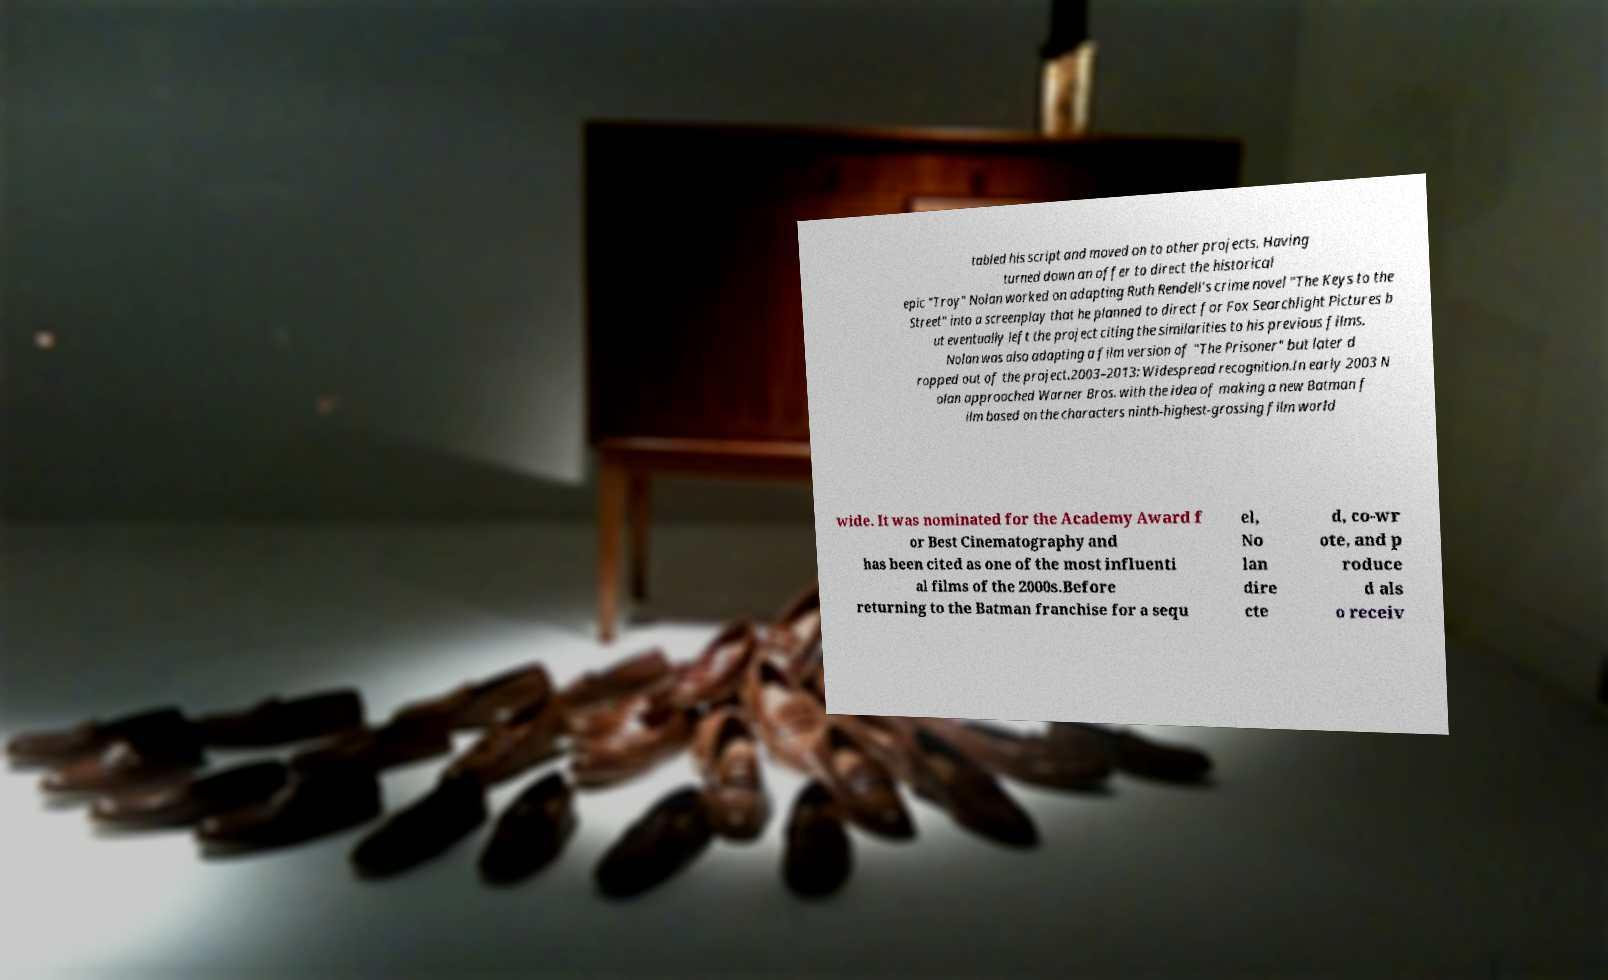Could you assist in decoding the text presented in this image and type it out clearly? tabled his script and moved on to other projects. Having turned down an offer to direct the historical epic "Troy" Nolan worked on adapting Ruth Rendell's crime novel "The Keys to the Street" into a screenplay that he planned to direct for Fox Searchlight Pictures b ut eventually left the project citing the similarities to his previous films. Nolan was also adapting a film version of "The Prisoner" but later d ropped out of the project.2003–2013: Widespread recognition.In early 2003 N olan approached Warner Bros. with the idea of making a new Batman f ilm based on the characters ninth-highest-grossing film world wide. It was nominated for the Academy Award f or Best Cinematography and has been cited as one of the most influenti al films of the 2000s.Before returning to the Batman franchise for a sequ el, No lan dire cte d, co-wr ote, and p roduce d als o receiv 